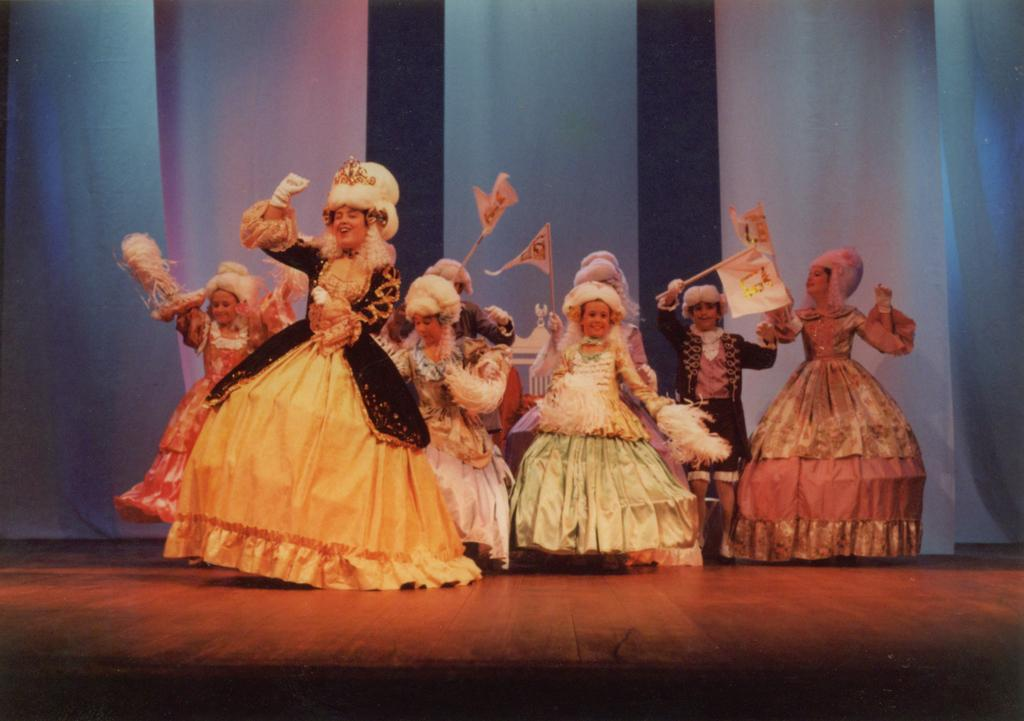How many people are in the image? There is a group of people in the image. Where are the people located in the image? The people are standing on a dais. What can be seen in the background of the image? There is a white curtain in the background of the image. How many fingers does the passenger in the image have? There is no passenger present in the image, as the main subject is a group of people standing on a dais. 